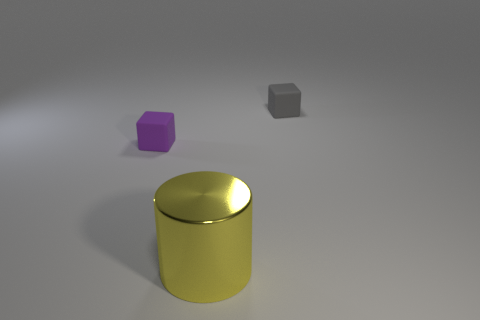Add 1 rubber things. How many objects exist? 4 Subtract all cylinders. How many objects are left? 2 Add 1 purple rubber cubes. How many purple rubber cubes exist? 2 Subtract 0 brown cylinders. How many objects are left? 3 Subtract all big things. Subtract all small gray blocks. How many objects are left? 1 Add 1 gray blocks. How many gray blocks are left? 2 